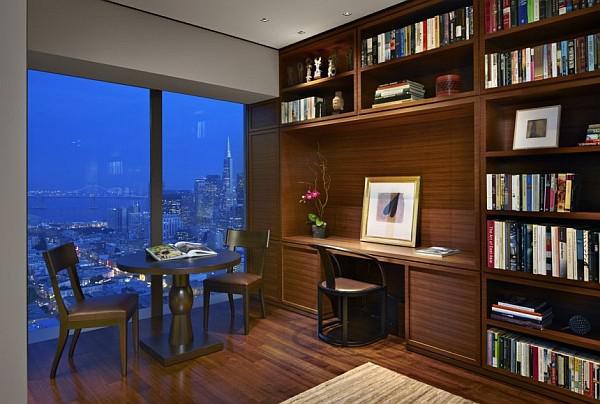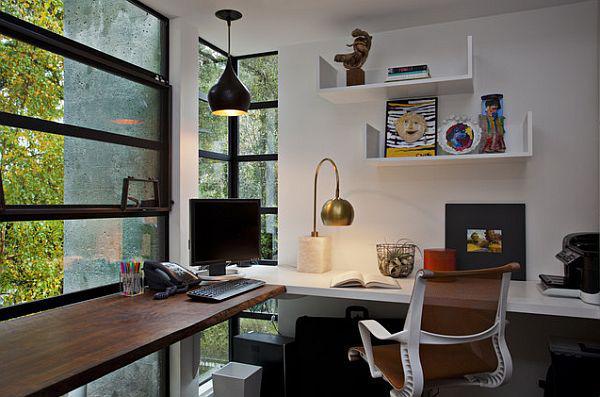The first image is the image on the left, the second image is the image on the right. Evaluate the accuracy of this statement regarding the images: "The left image shows at least one chair in front of a pair of windows with a blue glow, and shelving along one wall.". Is it true? Answer yes or no. Yes. The first image is the image on the left, the second image is the image on the right. Assess this claim about the two images: "THere are at least three floating bookshelves next to a twin bed.". Correct or not? Answer yes or no. No. 